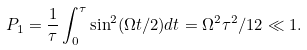<formula> <loc_0><loc_0><loc_500><loc_500>P _ { 1 } = \frac { 1 } { \tau } \int _ { 0 } ^ { \tau } \sin ^ { 2 } ( \Omega t / 2 ) d t = \Omega ^ { 2 } \tau ^ { 2 } / 1 2 \ll 1 .</formula> 